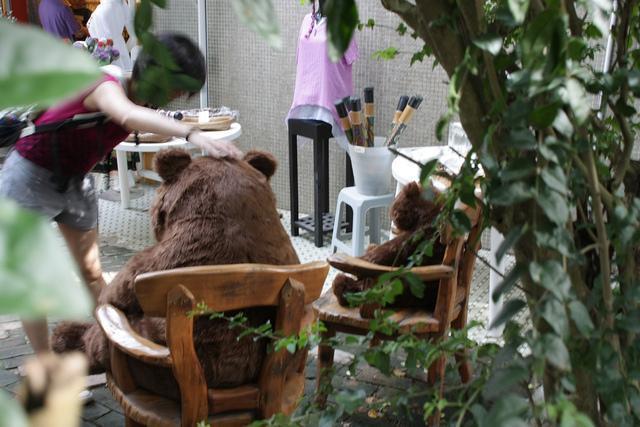How many bears are there?
Pick the correct solution from the four options below to address the question.
Options: Two, twenty, three, none. Two. 